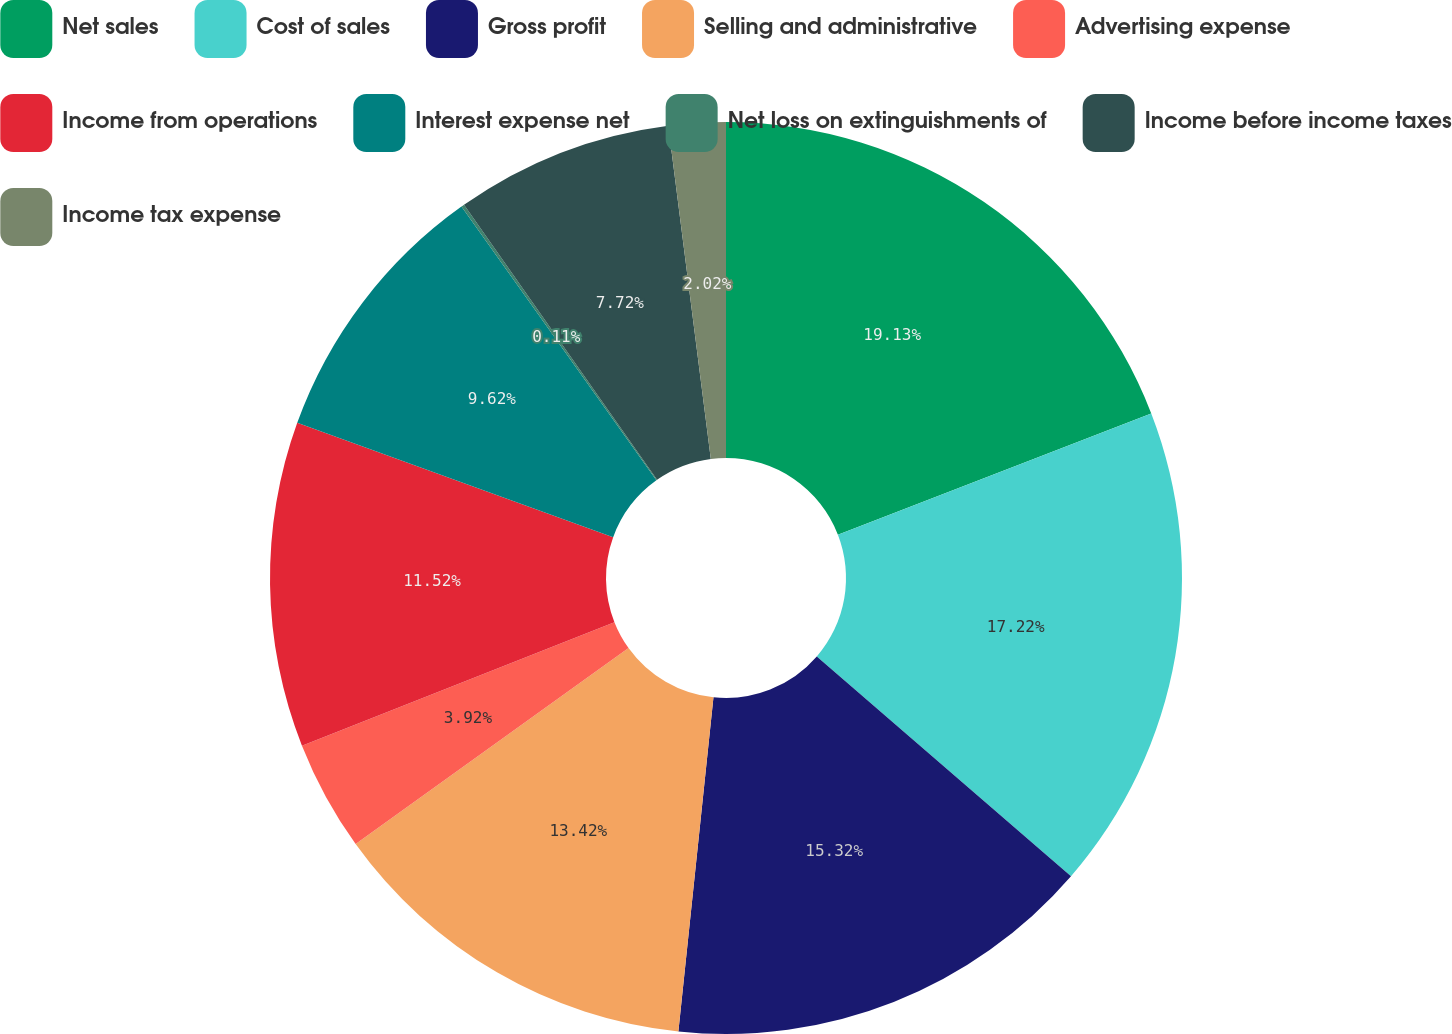Convert chart. <chart><loc_0><loc_0><loc_500><loc_500><pie_chart><fcel>Net sales<fcel>Cost of sales<fcel>Gross profit<fcel>Selling and administrative<fcel>Advertising expense<fcel>Income from operations<fcel>Interest expense net<fcel>Net loss on extinguishments of<fcel>Income before income taxes<fcel>Income tax expense<nl><fcel>19.12%<fcel>17.22%<fcel>15.32%<fcel>13.42%<fcel>3.92%<fcel>11.52%<fcel>9.62%<fcel>0.11%<fcel>7.72%<fcel>2.02%<nl></chart> 